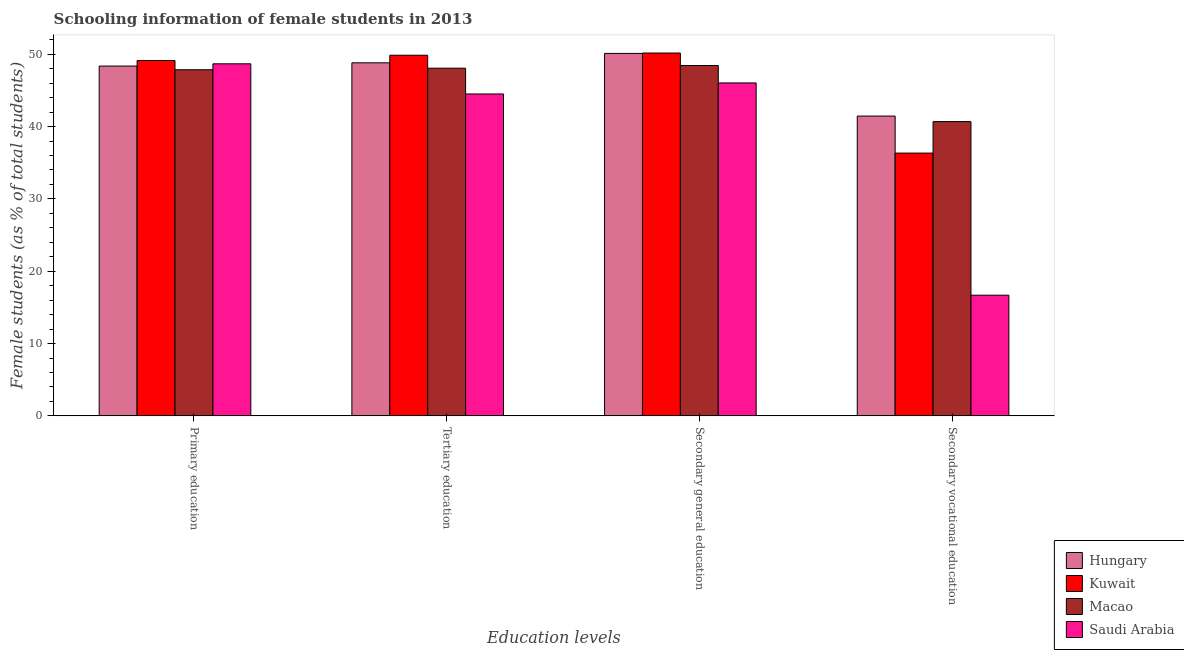How many different coloured bars are there?
Your response must be concise. 4. Are the number of bars per tick equal to the number of legend labels?
Give a very brief answer. Yes. Are the number of bars on each tick of the X-axis equal?
Ensure brevity in your answer.  Yes. How many bars are there on the 3rd tick from the left?
Your answer should be compact. 4. How many bars are there on the 3rd tick from the right?
Ensure brevity in your answer.  4. What is the label of the 1st group of bars from the left?
Provide a succinct answer. Primary education. What is the percentage of female students in tertiary education in Macao?
Keep it short and to the point. 48.07. Across all countries, what is the maximum percentage of female students in secondary vocational education?
Your answer should be compact. 41.45. Across all countries, what is the minimum percentage of female students in secondary vocational education?
Your answer should be compact. 16.68. In which country was the percentage of female students in tertiary education maximum?
Your answer should be very brief. Kuwait. In which country was the percentage of female students in tertiary education minimum?
Your response must be concise. Saudi Arabia. What is the total percentage of female students in secondary education in the graph?
Give a very brief answer. 194.75. What is the difference between the percentage of female students in tertiary education in Hungary and that in Saudi Arabia?
Your response must be concise. 4.31. What is the difference between the percentage of female students in primary education in Kuwait and the percentage of female students in secondary vocational education in Hungary?
Ensure brevity in your answer.  7.68. What is the average percentage of female students in primary education per country?
Provide a succinct answer. 48.51. What is the difference between the percentage of female students in primary education and percentage of female students in secondary education in Saudi Arabia?
Make the answer very short. 2.64. What is the ratio of the percentage of female students in tertiary education in Macao to that in Kuwait?
Your answer should be compact. 0.96. Is the percentage of female students in tertiary education in Macao less than that in Saudi Arabia?
Keep it short and to the point. No. What is the difference between the highest and the second highest percentage of female students in primary education?
Your response must be concise. 0.46. What is the difference between the highest and the lowest percentage of female students in primary education?
Offer a very short reply. 1.28. In how many countries, is the percentage of female students in tertiary education greater than the average percentage of female students in tertiary education taken over all countries?
Provide a short and direct response. 3. Is it the case that in every country, the sum of the percentage of female students in secondary vocational education and percentage of female students in secondary education is greater than the sum of percentage of female students in primary education and percentage of female students in tertiary education?
Offer a terse response. No. What does the 2nd bar from the left in Primary education represents?
Make the answer very short. Kuwait. What does the 1st bar from the right in Tertiary education represents?
Your answer should be compact. Saudi Arabia. Are all the bars in the graph horizontal?
Offer a terse response. No. How many countries are there in the graph?
Offer a terse response. 4. Are the values on the major ticks of Y-axis written in scientific E-notation?
Make the answer very short. No. Does the graph contain any zero values?
Keep it short and to the point. No. Does the graph contain grids?
Make the answer very short. No. How many legend labels are there?
Ensure brevity in your answer.  4. How are the legend labels stacked?
Ensure brevity in your answer.  Vertical. What is the title of the graph?
Your answer should be very brief. Schooling information of female students in 2013. Does "Luxembourg" appear as one of the legend labels in the graph?
Keep it short and to the point. No. What is the label or title of the X-axis?
Your answer should be very brief. Education levels. What is the label or title of the Y-axis?
Give a very brief answer. Female students (as % of total students). What is the Female students (as % of total students) in Hungary in Primary education?
Your response must be concise. 48.36. What is the Female students (as % of total students) of Kuwait in Primary education?
Your response must be concise. 49.13. What is the Female students (as % of total students) in Macao in Primary education?
Provide a short and direct response. 47.86. What is the Female students (as % of total students) of Saudi Arabia in Primary education?
Provide a succinct answer. 48.68. What is the Female students (as % of total students) in Hungary in Tertiary education?
Offer a terse response. 48.81. What is the Female students (as % of total students) of Kuwait in Tertiary education?
Your response must be concise. 49.86. What is the Female students (as % of total students) in Macao in Tertiary education?
Your answer should be compact. 48.07. What is the Female students (as % of total students) of Saudi Arabia in Tertiary education?
Your response must be concise. 44.51. What is the Female students (as % of total students) in Hungary in Secondary general education?
Offer a very short reply. 50.11. What is the Female students (as % of total students) in Kuwait in Secondary general education?
Give a very brief answer. 50.17. What is the Female students (as % of total students) in Macao in Secondary general education?
Offer a very short reply. 48.44. What is the Female students (as % of total students) in Saudi Arabia in Secondary general education?
Your response must be concise. 46.03. What is the Female students (as % of total students) of Hungary in Secondary vocational education?
Your answer should be very brief. 41.45. What is the Female students (as % of total students) of Kuwait in Secondary vocational education?
Keep it short and to the point. 36.33. What is the Female students (as % of total students) in Macao in Secondary vocational education?
Ensure brevity in your answer.  40.69. What is the Female students (as % of total students) in Saudi Arabia in Secondary vocational education?
Your answer should be compact. 16.68. Across all Education levels, what is the maximum Female students (as % of total students) of Hungary?
Your answer should be compact. 50.11. Across all Education levels, what is the maximum Female students (as % of total students) of Kuwait?
Your answer should be compact. 50.17. Across all Education levels, what is the maximum Female students (as % of total students) in Macao?
Provide a succinct answer. 48.44. Across all Education levels, what is the maximum Female students (as % of total students) in Saudi Arabia?
Keep it short and to the point. 48.68. Across all Education levels, what is the minimum Female students (as % of total students) in Hungary?
Ensure brevity in your answer.  41.45. Across all Education levels, what is the minimum Female students (as % of total students) of Kuwait?
Make the answer very short. 36.33. Across all Education levels, what is the minimum Female students (as % of total students) in Macao?
Provide a short and direct response. 40.69. Across all Education levels, what is the minimum Female students (as % of total students) in Saudi Arabia?
Your response must be concise. 16.68. What is the total Female students (as % of total students) in Hungary in the graph?
Your response must be concise. 188.74. What is the total Female students (as % of total students) in Kuwait in the graph?
Make the answer very short. 185.5. What is the total Female students (as % of total students) of Macao in the graph?
Offer a terse response. 185.05. What is the total Female students (as % of total students) in Saudi Arabia in the graph?
Keep it short and to the point. 155.9. What is the difference between the Female students (as % of total students) of Hungary in Primary education and that in Tertiary education?
Offer a very short reply. -0.45. What is the difference between the Female students (as % of total students) of Kuwait in Primary education and that in Tertiary education?
Make the answer very short. -0.73. What is the difference between the Female students (as % of total students) in Macao in Primary education and that in Tertiary education?
Give a very brief answer. -0.21. What is the difference between the Female students (as % of total students) of Saudi Arabia in Primary education and that in Tertiary education?
Provide a short and direct response. 4.17. What is the difference between the Female students (as % of total students) in Hungary in Primary education and that in Secondary general education?
Keep it short and to the point. -1.75. What is the difference between the Female students (as % of total students) of Kuwait in Primary education and that in Secondary general education?
Make the answer very short. -1.03. What is the difference between the Female students (as % of total students) in Macao in Primary education and that in Secondary general education?
Provide a succinct answer. -0.58. What is the difference between the Female students (as % of total students) of Saudi Arabia in Primary education and that in Secondary general education?
Give a very brief answer. 2.64. What is the difference between the Female students (as % of total students) of Hungary in Primary education and that in Secondary vocational education?
Offer a terse response. 6.91. What is the difference between the Female students (as % of total students) of Kuwait in Primary education and that in Secondary vocational education?
Provide a succinct answer. 12.8. What is the difference between the Female students (as % of total students) in Macao in Primary education and that in Secondary vocational education?
Provide a short and direct response. 7.17. What is the difference between the Female students (as % of total students) in Saudi Arabia in Primary education and that in Secondary vocational education?
Keep it short and to the point. 31.99. What is the difference between the Female students (as % of total students) in Hungary in Tertiary education and that in Secondary general education?
Ensure brevity in your answer.  -1.3. What is the difference between the Female students (as % of total students) of Kuwait in Tertiary education and that in Secondary general education?
Your answer should be very brief. -0.31. What is the difference between the Female students (as % of total students) of Macao in Tertiary education and that in Secondary general education?
Provide a succinct answer. -0.37. What is the difference between the Female students (as % of total students) of Saudi Arabia in Tertiary education and that in Secondary general education?
Your answer should be very brief. -1.53. What is the difference between the Female students (as % of total students) in Hungary in Tertiary education and that in Secondary vocational education?
Ensure brevity in your answer.  7.36. What is the difference between the Female students (as % of total students) in Kuwait in Tertiary education and that in Secondary vocational education?
Offer a very short reply. 13.53. What is the difference between the Female students (as % of total students) of Macao in Tertiary education and that in Secondary vocational education?
Your answer should be very brief. 7.39. What is the difference between the Female students (as % of total students) in Saudi Arabia in Tertiary education and that in Secondary vocational education?
Ensure brevity in your answer.  27.82. What is the difference between the Female students (as % of total students) of Hungary in Secondary general education and that in Secondary vocational education?
Give a very brief answer. 8.66. What is the difference between the Female students (as % of total students) of Kuwait in Secondary general education and that in Secondary vocational education?
Offer a terse response. 13.84. What is the difference between the Female students (as % of total students) in Macao in Secondary general education and that in Secondary vocational education?
Ensure brevity in your answer.  7.75. What is the difference between the Female students (as % of total students) in Saudi Arabia in Secondary general education and that in Secondary vocational education?
Your answer should be compact. 29.35. What is the difference between the Female students (as % of total students) of Hungary in Primary education and the Female students (as % of total students) of Kuwait in Tertiary education?
Keep it short and to the point. -1.5. What is the difference between the Female students (as % of total students) of Hungary in Primary education and the Female students (as % of total students) of Macao in Tertiary education?
Provide a succinct answer. 0.29. What is the difference between the Female students (as % of total students) in Hungary in Primary education and the Female students (as % of total students) in Saudi Arabia in Tertiary education?
Make the answer very short. 3.86. What is the difference between the Female students (as % of total students) of Kuwait in Primary education and the Female students (as % of total students) of Macao in Tertiary education?
Give a very brief answer. 1.06. What is the difference between the Female students (as % of total students) of Kuwait in Primary education and the Female students (as % of total students) of Saudi Arabia in Tertiary education?
Give a very brief answer. 4.63. What is the difference between the Female students (as % of total students) in Macao in Primary education and the Female students (as % of total students) in Saudi Arabia in Tertiary education?
Make the answer very short. 3.35. What is the difference between the Female students (as % of total students) of Hungary in Primary education and the Female students (as % of total students) of Kuwait in Secondary general education?
Make the answer very short. -1.8. What is the difference between the Female students (as % of total students) in Hungary in Primary education and the Female students (as % of total students) in Macao in Secondary general education?
Your answer should be compact. -0.07. What is the difference between the Female students (as % of total students) of Hungary in Primary education and the Female students (as % of total students) of Saudi Arabia in Secondary general education?
Provide a short and direct response. 2.33. What is the difference between the Female students (as % of total students) of Kuwait in Primary education and the Female students (as % of total students) of Macao in Secondary general education?
Ensure brevity in your answer.  0.7. What is the difference between the Female students (as % of total students) of Kuwait in Primary education and the Female students (as % of total students) of Saudi Arabia in Secondary general education?
Your response must be concise. 3.1. What is the difference between the Female students (as % of total students) of Macao in Primary education and the Female students (as % of total students) of Saudi Arabia in Secondary general education?
Keep it short and to the point. 1.82. What is the difference between the Female students (as % of total students) in Hungary in Primary education and the Female students (as % of total students) in Kuwait in Secondary vocational education?
Provide a succinct answer. 12.03. What is the difference between the Female students (as % of total students) of Hungary in Primary education and the Female students (as % of total students) of Macao in Secondary vocational education?
Keep it short and to the point. 7.68. What is the difference between the Female students (as % of total students) in Hungary in Primary education and the Female students (as % of total students) in Saudi Arabia in Secondary vocational education?
Your answer should be compact. 31.68. What is the difference between the Female students (as % of total students) in Kuwait in Primary education and the Female students (as % of total students) in Macao in Secondary vocational education?
Make the answer very short. 8.45. What is the difference between the Female students (as % of total students) in Kuwait in Primary education and the Female students (as % of total students) in Saudi Arabia in Secondary vocational education?
Your response must be concise. 32.45. What is the difference between the Female students (as % of total students) of Macao in Primary education and the Female students (as % of total students) of Saudi Arabia in Secondary vocational education?
Your response must be concise. 31.17. What is the difference between the Female students (as % of total students) in Hungary in Tertiary education and the Female students (as % of total students) in Kuwait in Secondary general education?
Ensure brevity in your answer.  -1.36. What is the difference between the Female students (as % of total students) of Hungary in Tertiary education and the Female students (as % of total students) of Macao in Secondary general education?
Your answer should be compact. 0.37. What is the difference between the Female students (as % of total students) of Hungary in Tertiary education and the Female students (as % of total students) of Saudi Arabia in Secondary general education?
Your answer should be compact. 2.78. What is the difference between the Female students (as % of total students) of Kuwait in Tertiary education and the Female students (as % of total students) of Macao in Secondary general education?
Offer a terse response. 1.42. What is the difference between the Female students (as % of total students) in Kuwait in Tertiary education and the Female students (as % of total students) in Saudi Arabia in Secondary general education?
Provide a succinct answer. 3.83. What is the difference between the Female students (as % of total students) in Macao in Tertiary education and the Female students (as % of total students) in Saudi Arabia in Secondary general education?
Offer a terse response. 2.04. What is the difference between the Female students (as % of total students) in Hungary in Tertiary education and the Female students (as % of total students) in Kuwait in Secondary vocational education?
Offer a very short reply. 12.48. What is the difference between the Female students (as % of total students) in Hungary in Tertiary education and the Female students (as % of total students) in Macao in Secondary vocational education?
Your response must be concise. 8.13. What is the difference between the Female students (as % of total students) of Hungary in Tertiary education and the Female students (as % of total students) of Saudi Arabia in Secondary vocational education?
Make the answer very short. 32.13. What is the difference between the Female students (as % of total students) in Kuwait in Tertiary education and the Female students (as % of total students) in Macao in Secondary vocational education?
Your response must be concise. 9.17. What is the difference between the Female students (as % of total students) of Kuwait in Tertiary education and the Female students (as % of total students) of Saudi Arabia in Secondary vocational education?
Ensure brevity in your answer.  33.18. What is the difference between the Female students (as % of total students) in Macao in Tertiary education and the Female students (as % of total students) in Saudi Arabia in Secondary vocational education?
Provide a succinct answer. 31.39. What is the difference between the Female students (as % of total students) in Hungary in Secondary general education and the Female students (as % of total students) in Kuwait in Secondary vocational education?
Your answer should be very brief. 13.78. What is the difference between the Female students (as % of total students) of Hungary in Secondary general education and the Female students (as % of total students) of Macao in Secondary vocational education?
Your answer should be very brief. 9.43. What is the difference between the Female students (as % of total students) in Hungary in Secondary general education and the Female students (as % of total students) in Saudi Arabia in Secondary vocational education?
Offer a terse response. 33.43. What is the difference between the Female students (as % of total students) of Kuwait in Secondary general education and the Female students (as % of total students) of Macao in Secondary vocational education?
Make the answer very short. 9.48. What is the difference between the Female students (as % of total students) in Kuwait in Secondary general education and the Female students (as % of total students) in Saudi Arabia in Secondary vocational education?
Provide a succinct answer. 33.48. What is the difference between the Female students (as % of total students) in Macao in Secondary general education and the Female students (as % of total students) in Saudi Arabia in Secondary vocational education?
Ensure brevity in your answer.  31.75. What is the average Female students (as % of total students) in Hungary per Education levels?
Make the answer very short. 47.19. What is the average Female students (as % of total students) of Kuwait per Education levels?
Offer a very short reply. 46.37. What is the average Female students (as % of total students) in Macao per Education levels?
Ensure brevity in your answer.  46.26. What is the average Female students (as % of total students) in Saudi Arabia per Education levels?
Your answer should be very brief. 38.98. What is the difference between the Female students (as % of total students) in Hungary and Female students (as % of total students) in Kuwait in Primary education?
Your answer should be very brief. -0.77. What is the difference between the Female students (as % of total students) of Hungary and Female students (as % of total students) of Macao in Primary education?
Make the answer very short. 0.51. What is the difference between the Female students (as % of total students) of Hungary and Female students (as % of total students) of Saudi Arabia in Primary education?
Offer a very short reply. -0.31. What is the difference between the Female students (as % of total students) of Kuwait and Female students (as % of total students) of Macao in Primary education?
Your answer should be very brief. 1.28. What is the difference between the Female students (as % of total students) in Kuwait and Female students (as % of total students) in Saudi Arabia in Primary education?
Your response must be concise. 0.46. What is the difference between the Female students (as % of total students) in Macao and Female students (as % of total students) in Saudi Arabia in Primary education?
Your response must be concise. -0.82. What is the difference between the Female students (as % of total students) in Hungary and Female students (as % of total students) in Kuwait in Tertiary education?
Make the answer very short. -1.05. What is the difference between the Female students (as % of total students) in Hungary and Female students (as % of total students) in Macao in Tertiary education?
Ensure brevity in your answer.  0.74. What is the difference between the Female students (as % of total students) in Hungary and Female students (as % of total students) in Saudi Arabia in Tertiary education?
Offer a terse response. 4.31. What is the difference between the Female students (as % of total students) of Kuwait and Female students (as % of total students) of Macao in Tertiary education?
Your answer should be very brief. 1.79. What is the difference between the Female students (as % of total students) of Kuwait and Female students (as % of total students) of Saudi Arabia in Tertiary education?
Ensure brevity in your answer.  5.35. What is the difference between the Female students (as % of total students) in Macao and Female students (as % of total students) in Saudi Arabia in Tertiary education?
Offer a very short reply. 3.56. What is the difference between the Female students (as % of total students) of Hungary and Female students (as % of total students) of Kuwait in Secondary general education?
Keep it short and to the point. -0.06. What is the difference between the Female students (as % of total students) of Hungary and Female students (as % of total students) of Macao in Secondary general education?
Give a very brief answer. 1.68. What is the difference between the Female students (as % of total students) in Hungary and Female students (as % of total students) in Saudi Arabia in Secondary general education?
Your answer should be compact. 4.08. What is the difference between the Female students (as % of total students) of Kuwait and Female students (as % of total students) of Macao in Secondary general education?
Make the answer very short. 1.73. What is the difference between the Female students (as % of total students) of Kuwait and Female students (as % of total students) of Saudi Arabia in Secondary general education?
Your answer should be very brief. 4.13. What is the difference between the Female students (as % of total students) in Macao and Female students (as % of total students) in Saudi Arabia in Secondary general education?
Ensure brevity in your answer.  2.4. What is the difference between the Female students (as % of total students) in Hungary and Female students (as % of total students) in Kuwait in Secondary vocational education?
Ensure brevity in your answer.  5.12. What is the difference between the Female students (as % of total students) of Hungary and Female students (as % of total students) of Macao in Secondary vocational education?
Offer a very short reply. 0.77. What is the difference between the Female students (as % of total students) in Hungary and Female students (as % of total students) in Saudi Arabia in Secondary vocational education?
Offer a terse response. 24.77. What is the difference between the Female students (as % of total students) in Kuwait and Female students (as % of total students) in Macao in Secondary vocational education?
Your response must be concise. -4.35. What is the difference between the Female students (as % of total students) in Kuwait and Female students (as % of total students) in Saudi Arabia in Secondary vocational education?
Your answer should be compact. 19.65. What is the difference between the Female students (as % of total students) in Macao and Female students (as % of total students) in Saudi Arabia in Secondary vocational education?
Ensure brevity in your answer.  24. What is the ratio of the Female students (as % of total students) of Hungary in Primary education to that in Tertiary education?
Your answer should be compact. 0.99. What is the ratio of the Female students (as % of total students) of Kuwait in Primary education to that in Tertiary education?
Provide a succinct answer. 0.99. What is the ratio of the Female students (as % of total students) in Macao in Primary education to that in Tertiary education?
Offer a very short reply. 1. What is the ratio of the Female students (as % of total students) of Saudi Arabia in Primary education to that in Tertiary education?
Give a very brief answer. 1.09. What is the ratio of the Female students (as % of total students) in Hungary in Primary education to that in Secondary general education?
Your answer should be compact. 0.97. What is the ratio of the Female students (as % of total students) in Kuwait in Primary education to that in Secondary general education?
Offer a terse response. 0.98. What is the ratio of the Female students (as % of total students) in Saudi Arabia in Primary education to that in Secondary general education?
Keep it short and to the point. 1.06. What is the ratio of the Female students (as % of total students) of Hungary in Primary education to that in Secondary vocational education?
Offer a terse response. 1.17. What is the ratio of the Female students (as % of total students) in Kuwait in Primary education to that in Secondary vocational education?
Ensure brevity in your answer.  1.35. What is the ratio of the Female students (as % of total students) of Macao in Primary education to that in Secondary vocational education?
Provide a succinct answer. 1.18. What is the ratio of the Female students (as % of total students) in Saudi Arabia in Primary education to that in Secondary vocational education?
Provide a short and direct response. 2.92. What is the ratio of the Female students (as % of total students) of Kuwait in Tertiary education to that in Secondary general education?
Keep it short and to the point. 0.99. What is the ratio of the Female students (as % of total students) of Saudi Arabia in Tertiary education to that in Secondary general education?
Your answer should be compact. 0.97. What is the ratio of the Female students (as % of total students) in Hungary in Tertiary education to that in Secondary vocational education?
Offer a very short reply. 1.18. What is the ratio of the Female students (as % of total students) in Kuwait in Tertiary education to that in Secondary vocational education?
Give a very brief answer. 1.37. What is the ratio of the Female students (as % of total students) in Macao in Tertiary education to that in Secondary vocational education?
Keep it short and to the point. 1.18. What is the ratio of the Female students (as % of total students) in Saudi Arabia in Tertiary education to that in Secondary vocational education?
Provide a succinct answer. 2.67. What is the ratio of the Female students (as % of total students) in Hungary in Secondary general education to that in Secondary vocational education?
Offer a terse response. 1.21. What is the ratio of the Female students (as % of total students) in Kuwait in Secondary general education to that in Secondary vocational education?
Your answer should be very brief. 1.38. What is the ratio of the Female students (as % of total students) of Macao in Secondary general education to that in Secondary vocational education?
Make the answer very short. 1.19. What is the ratio of the Female students (as % of total students) of Saudi Arabia in Secondary general education to that in Secondary vocational education?
Provide a short and direct response. 2.76. What is the difference between the highest and the second highest Female students (as % of total students) in Hungary?
Provide a succinct answer. 1.3. What is the difference between the highest and the second highest Female students (as % of total students) of Kuwait?
Offer a very short reply. 0.31. What is the difference between the highest and the second highest Female students (as % of total students) of Macao?
Your answer should be compact. 0.37. What is the difference between the highest and the second highest Female students (as % of total students) in Saudi Arabia?
Ensure brevity in your answer.  2.64. What is the difference between the highest and the lowest Female students (as % of total students) of Hungary?
Keep it short and to the point. 8.66. What is the difference between the highest and the lowest Female students (as % of total students) of Kuwait?
Provide a short and direct response. 13.84. What is the difference between the highest and the lowest Female students (as % of total students) of Macao?
Provide a succinct answer. 7.75. What is the difference between the highest and the lowest Female students (as % of total students) in Saudi Arabia?
Ensure brevity in your answer.  31.99. 